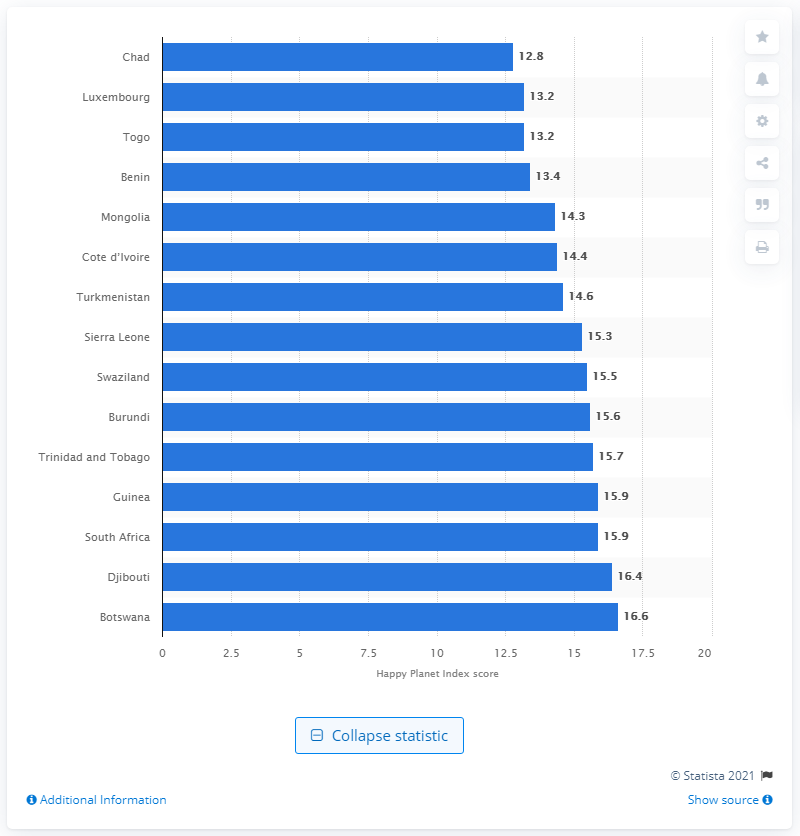Specify some key components in this picture. In 2016, Chad's HPI score was 12.8. 